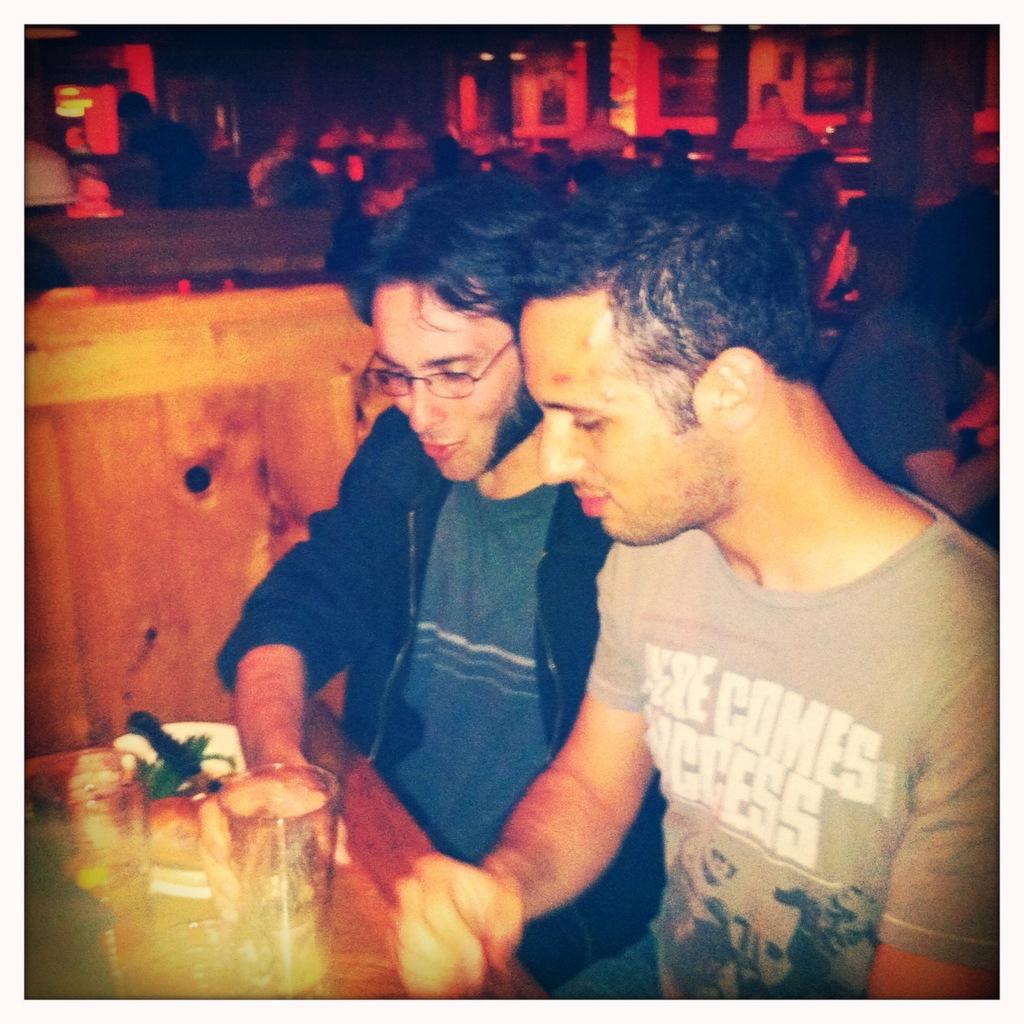In one or two sentences, can you explain what this image depicts? In this image, we can see persons wearing clothes. There is a person in the middle of the image holding a glass with his hand. There is a glass and plate on the table which is in the bottom left of the image. 